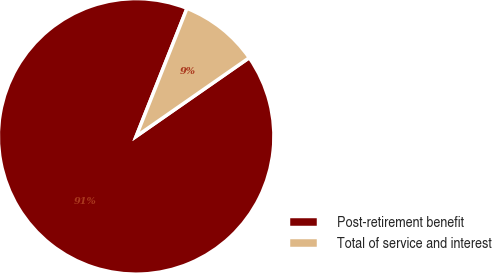<chart> <loc_0><loc_0><loc_500><loc_500><pie_chart><fcel>Post-retirement benefit<fcel>Total of service and interest<nl><fcel>90.69%<fcel>9.31%<nl></chart> 